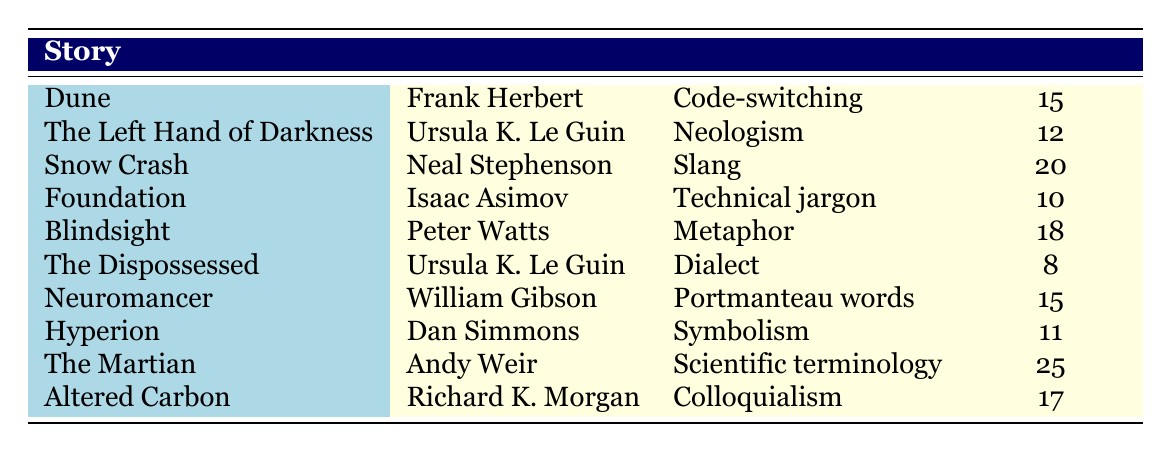What is the highest frequency of a linguistic feature listed in the table? The highest frequency is found in "The Martian" by Andy Weir with a frequency of 25.
Answer: 25 Which author used "neologism" as a linguistic feature in their story? According to the table, "neologism" is attributed to Ursula K. Le Guin in "The Left Hand of Darkness".
Answer: Ursula K. Le Guin How many stories feature slang or colloquialism? "Snow Crash" features slang (frequency 20) and "Altered Carbon" features colloquialism (frequency 17). This gives a total of 2 stories.
Answer: 2 What is the total frequency of technical jargon and metaphor used in the stories? The frequency for technical jargon in "Foundation" is 10, and for metaphor in "Blindsight" it is 18. Adding these gives 10 + 18 = 28.
Answer: 28 Is it true that "The Dispossessed" has a higher frequency of linguistic features than "Foundation"? "The Dispossessed" has a frequency of 8 while "Foundation" has a frequency of 10, therefore it is false that "The Dispossessed" has a higher frequency.
Answer: False Which story has a frequency that is closest to the average frequency of all linguistic features in the table? To find the average, we sum the frequencies (15 + 12 + 20 + 10 + 18 + 8 + 15 + 11 + 25 + 17) =  141, and divide by 10 (the number of stories), giving an average of 14.1. The closest frequency to this average is 15 (which corresponds to "Dune" and "Neuromancer").
Answer: 15 How many different linguistic features were identified across the stories? There are a total of 10 distinct linguistic features listed in the table.
Answer: 10 Which story by Frank Herbert features code-switching and what is its frequency? "Dune" by Frank Herbert features code-switching with a frequency of 15.
Answer: Dune, 15 